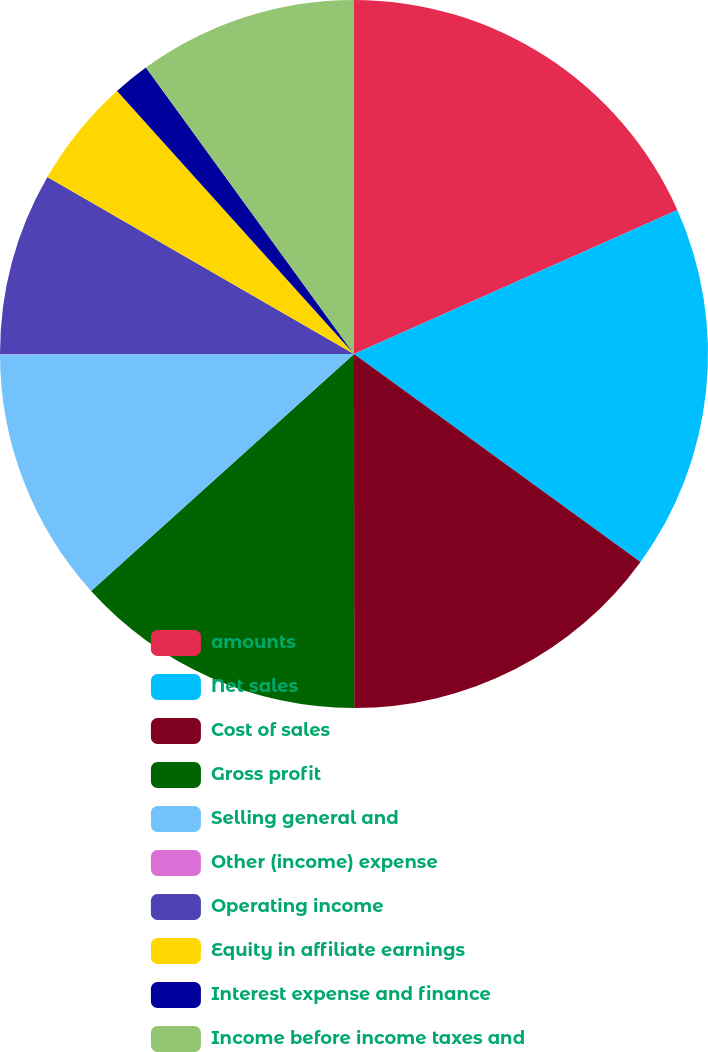<chart> <loc_0><loc_0><loc_500><loc_500><pie_chart><fcel>amounts<fcel>Net sales<fcel>Cost of sales<fcel>Gross profit<fcel>Selling general and<fcel>Other (income) expense<fcel>Operating income<fcel>Equity in affiliate earnings<fcel>Interest expense and finance<fcel>Income before income taxes and<nl><fcel>18.33%<fcel>16.66%<fcel>15.0%<fcel>13.33%<fcel>11.67%<fcel>0.01%<fcel>8.33%<fcel>5.0%<fcel>1.67%<fcel>10.0%<nl></chart> 